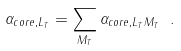<formula> <loc_0><loc_0><loc_500><loc_500>\alpha _ { c o r e , L _ { T } } = \sum _ { M _ { T } } \alpha _ { c o r e , L _ { T } M _ { T } } \ .</formula> 